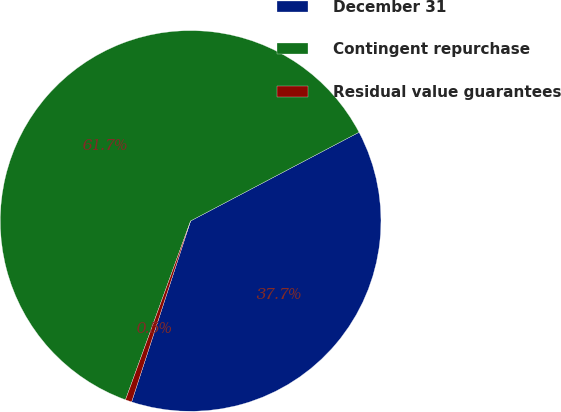<chart> <loc_0><loc_0><loc_500><loc_500><pie_chart><fcel>December 31<fcel>Contingent repurchase<fcel>Residual value guarantees<nl><fcel>37.73%<fcel>61.73%<fcel>0.54%<nl></chart> 